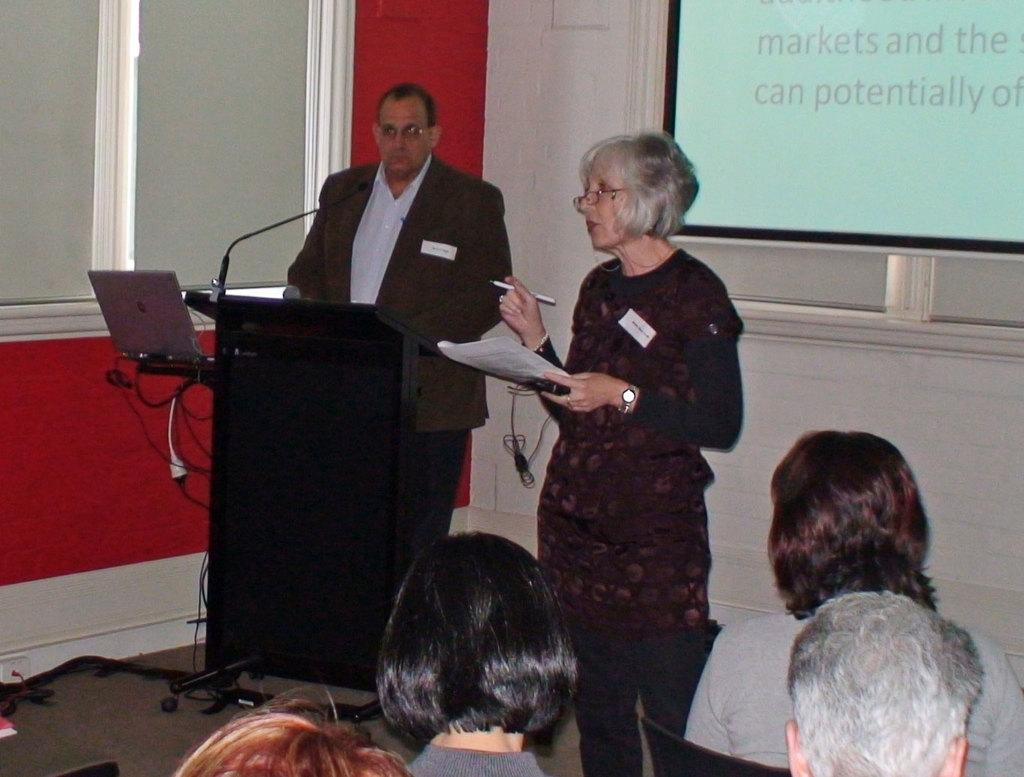What is the general arrangement of people in the room? There are people seated in the room, and two people are standing at the back. What equipment is present in the room? There is a microphone and a laptop in the room. Are there any visible wires in the room? Yes, there are wires on the tables in the room. What feature of the room allows for natural light or a view of the outdoors? There are windows in the room. What is being displayed at the back of the room? There is a projector display at the back of the room. What types of pets are visible in the room? There are no pets visible in the room. Is there a committee meeting taking place in the room? The image does not provide any information about a committee meeting or its purpose. 